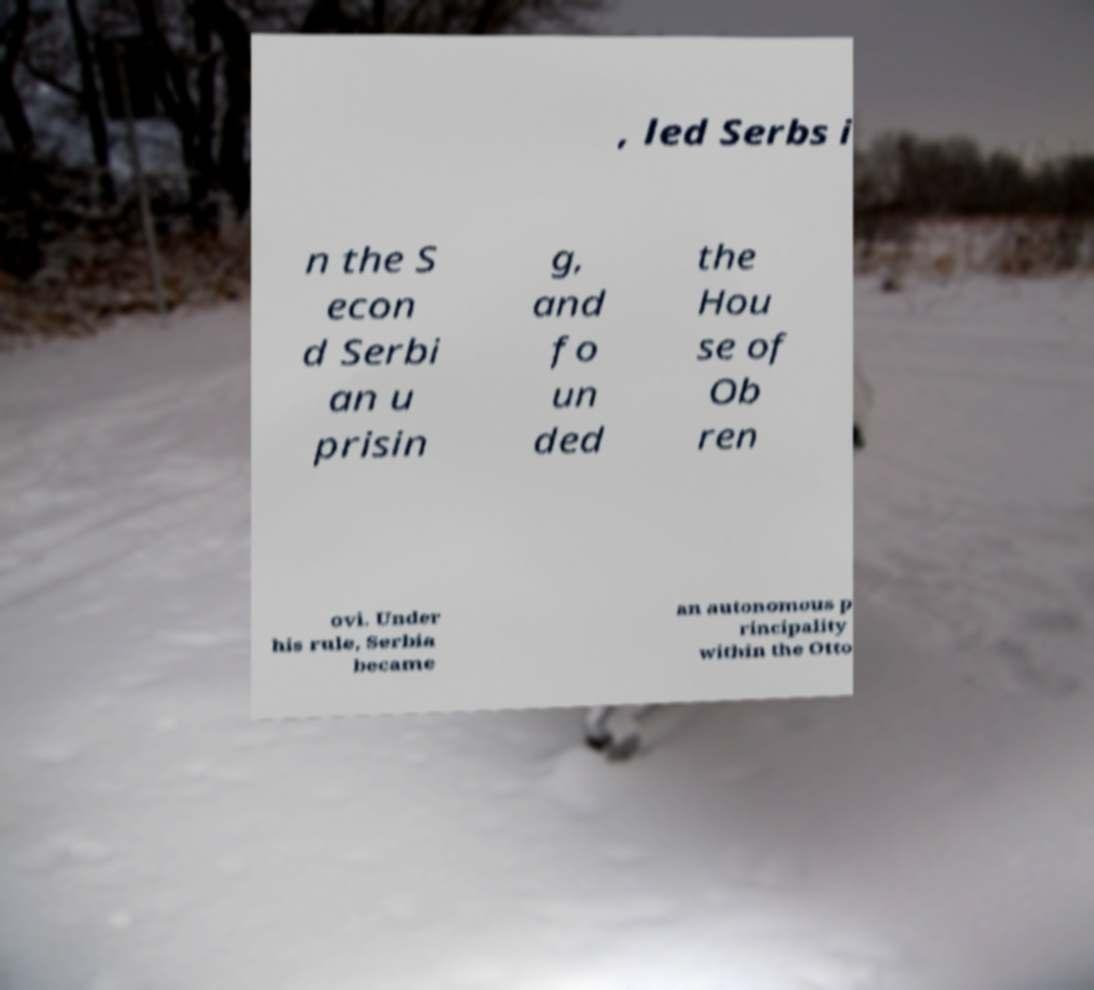Could you assist in decoding the text presented in this image and type it out clearly? , led Serbs i n the S econ d Serbi an u prisin g, and fo un ded the Hou se of Ob ren ovi. Under his rule, Serbia became an autonomous p rincipality within the Otto 